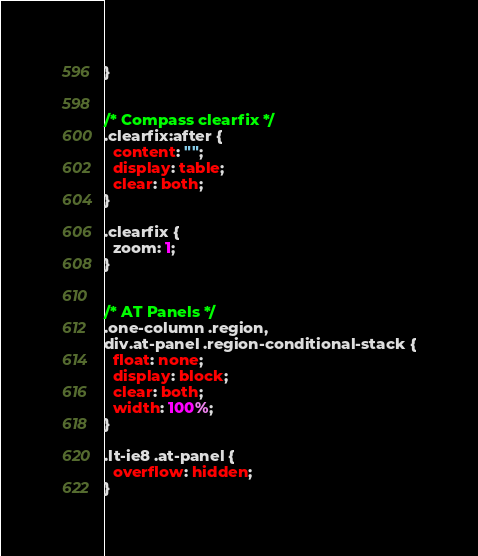Convert code to text. <code><loc_0><loc_0><loc_500><loc_500><_CSS_>}


/* Compass clearfix */
.clearfix:after {
  content: "";
  display: table;
  clear: both;
}

.clearfix {
  zoom: 1;
}


/* AT Panels */
.one-column .region,
div.at-panel .region-conditional-stack {
  float: none;
  display: block;
  clear: both;
  width: 100%;
}

.lt-ie8 .at-panel {
  overflow: hidden;
}
</code> 